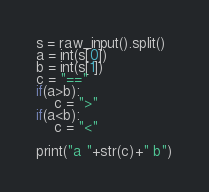<code> <loc_0><loc_0><loc_500><loc_500><_Python_>s = raw_input().split()
a = int(s[0])
b = int(s[1])
c = "=="
if(a>b):
	c = ">"
if(a<b):
	c = "<"

print("a "+str(c)+" b")

</code> 